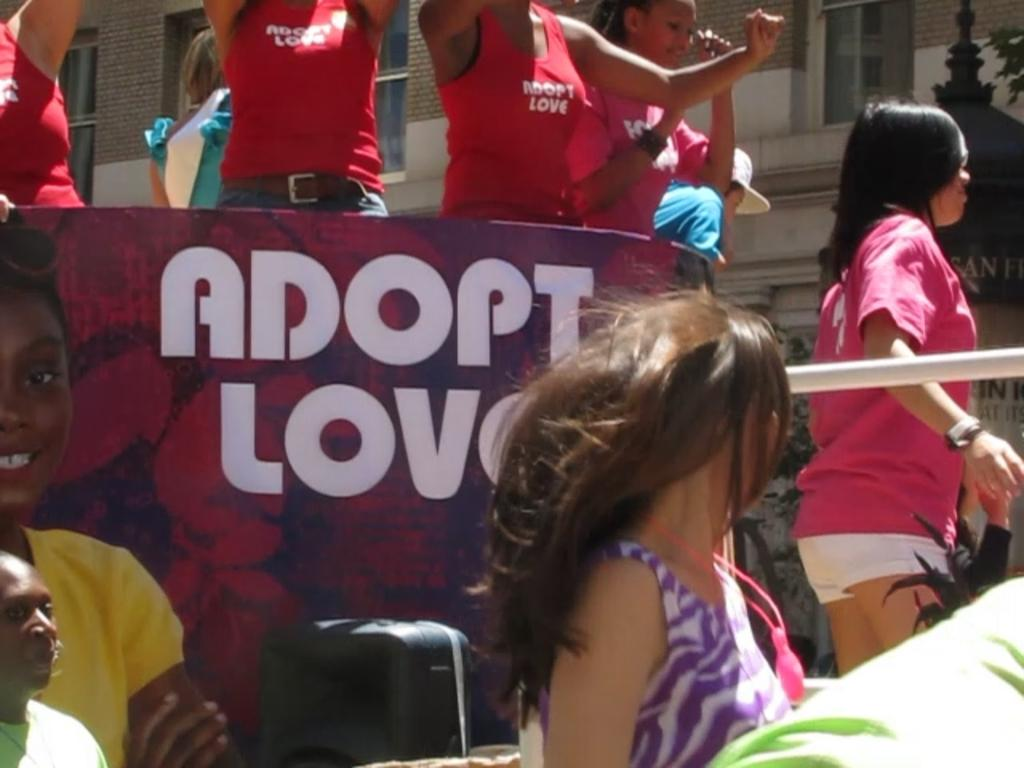<image>
Offer a succinct explanation of the picture presented. Adopt Love is printed on this sign advertisement. 